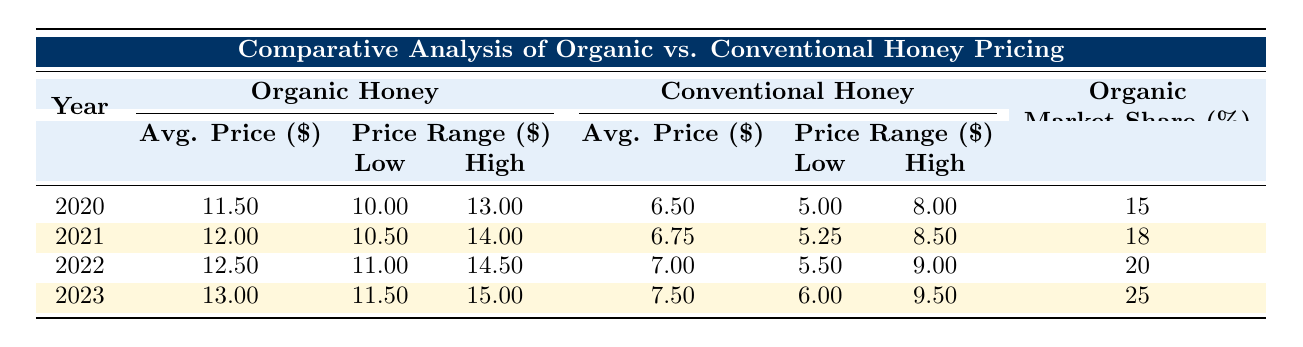What was the average price of organic honey in 2020? The table shows that the average price of organic honey in 2020 is listed under the "Organic Honey" column for the year 2020. This value is 11.50.
Answer: 11.50 In which year did conventional honey have the highest average price? By looking through the average prices for conventional honey from 2020 to 2023, the values are 6.50, 6.75, 7.00, and 7.50 respectively. The highest value is 7.50, which is in the year 2023.
Answer: 2023 What is the market share of organic honey in 2022? The market share of organic honey for the year 2022 is specified in the last column for that year, which is 20.
Answer: 20 Did the average price of organic honey increase every year from 2020 to 2023? By comparing the average prices for organic honey over the years: 11.50 (2020), 12.00 (2021), 12.50 (2022), and 13.00 (2023), it is evident that the price increased each year. Therefore, the statement is true.
Answer: Yes What is the difference in average price per pound between organic and conventional honey in 2021? In 2021, organic honey had an average price of 12.00, and conventional honey's average price was 6.75. The difference between these two prices is calculated as 12.00 - 6.75 = 5.25.
Answer: 5.25 Compare the average prices of organic honey between 2020 and 2023. What is the percentage increase? The average price of organic honey in 2020 was 11.50, and in 2023 it rose to 13.00. The percentage increase is calculated by the formula: ((13.00 - 11.50) / 11.50) * 100 = 13.04%. Therefore, there is an increase of 13.04%.
Answer: 13.04% Was the price range for organic honey wider in 2022 compared to 2021? In 2021, the price range for organic honey is from 10.50 to 14.00, which gives a range of 3.50. In 2022, the price range is from 11.00 to 14.50, resulting in a range of 3.50. Since both years have the same range, it is false to say it was wider in 2022.
Answer: No What was the lowest price of conventional honey in 2023? The table lists the lowest price of conventional honey for the year 2023 under the "Price Range" section, which is 6.00.
Answer: 6.00 